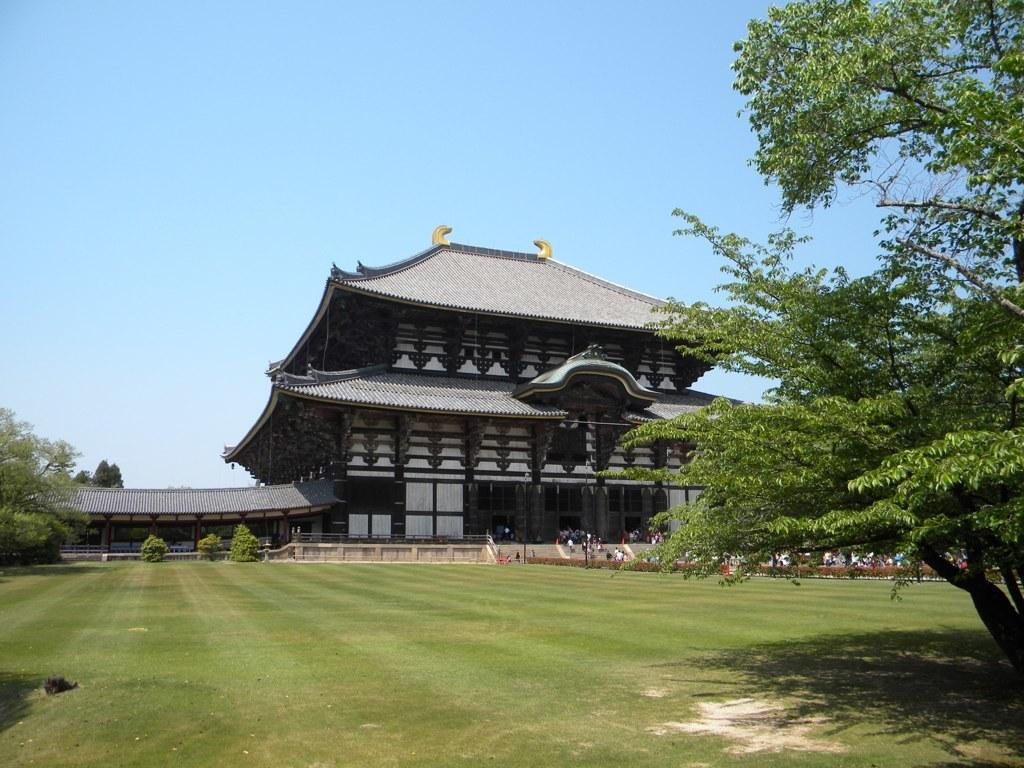What is the color of the sky in the image? The sky is blue in the image. What type of structure can be seen in the image? There is a building in the image. What is located in front of the building? Trees, people, and grass are present in front of the building. What channel is the building on in the image? The image is not a television channel, so there is no channel to reference. 